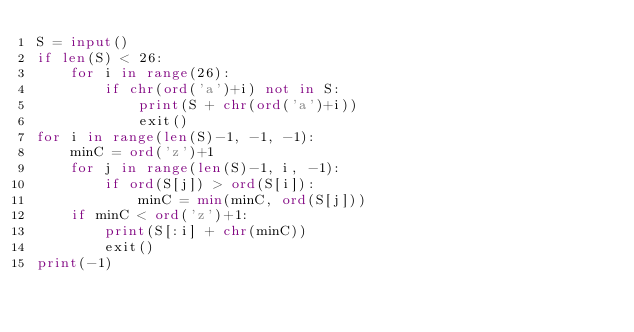<code> <loc_0><loc_0><loc_500><loc_500><_Python_>S = input()
if len(S) < 26:
    for i in range(26):
        if chr(ord('a')+i) not in S:
            print(S + chr(ord('a')+i))
            exit()
for i in range(len(S)-1, -1, -1):
    minC = ord('z')+1
    for j in range(len(S)-1, i, -1):
        if ord(S[j]) > ord(S[i]):
            minC = min(minC, ord(S[j]))
    if minC < ord('z')+1:
        print(S[:i] + chr(minC))
        exit()
print(-1)</code> 